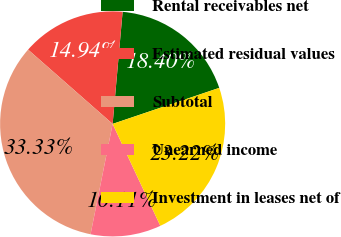<chart> <loc_0><loc_0><loc_500><loc_500><pie_chart><fcel>Rental receivables net<fcel>Estimated residual values<fcel>Subtotal<fcel>Unearned income<fcel>Investment in leases net of<nl><fcel>18.4%<fcel>14.94%<fcel>33.33%<fcel>10.11%<fcel>23.22%<nl></chart> 